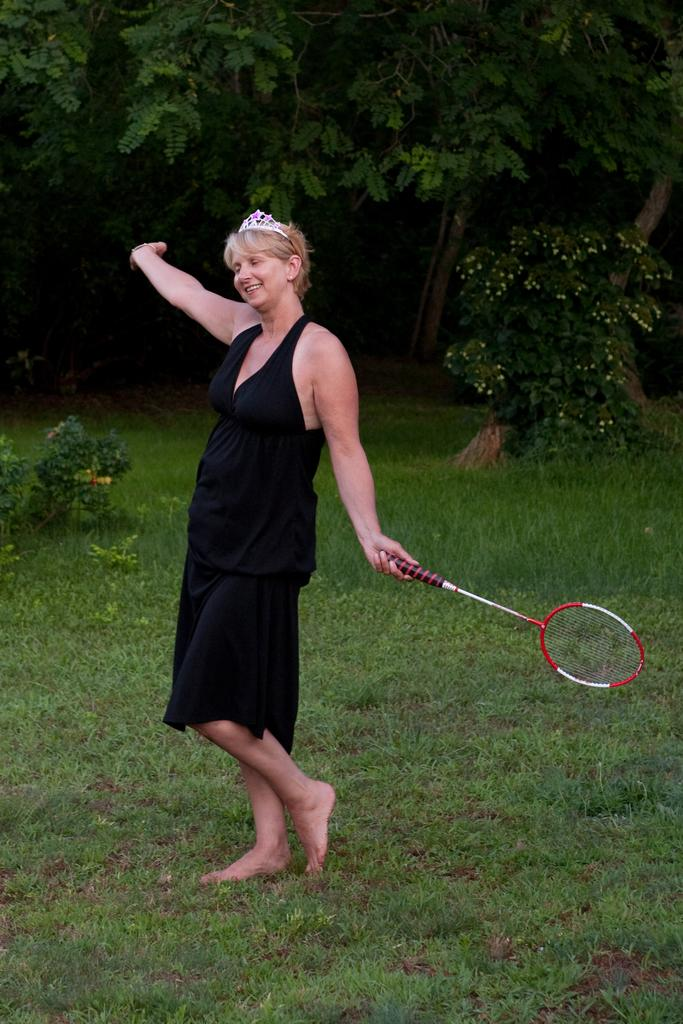Who is present in the image? There is a woman in the image. What is the woman doing in the image? The woman is standing and holding a tennis racket. What is the woman's facial expression in the image? The woman is smiling in the image. What can be seen in the background of the image? There are trees in the background of the image. What type of sweater is the woman wearing in the image? The image does not show the woman wearing a sweater; she is holding a tennis racket instead. 